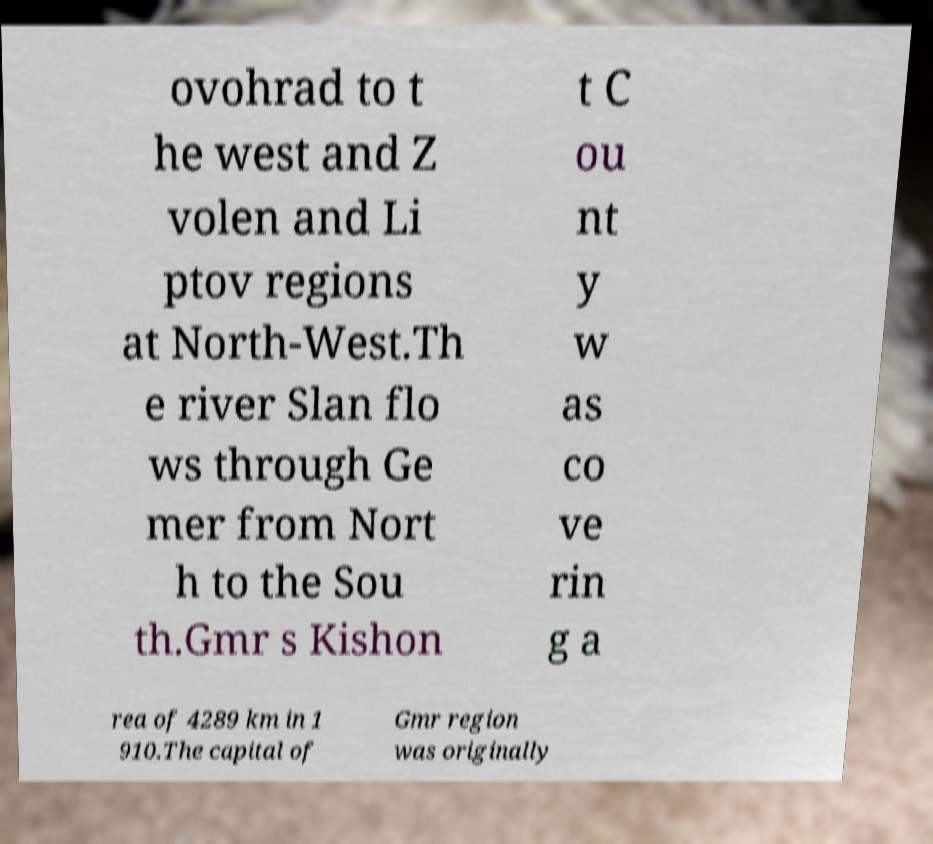Could you assist in decoding the text presented in this image and type it out clearly? ovohrad to t he west and Z volen and Li ptov regions at North-West.Th e river Slan flo ws through Ge mer from Nort h to the Sou th.Gmr s Kishon t C ou nt y w as co ve rin g a rea of 4289 km in 1 910.The capital of Gmr region was originally 